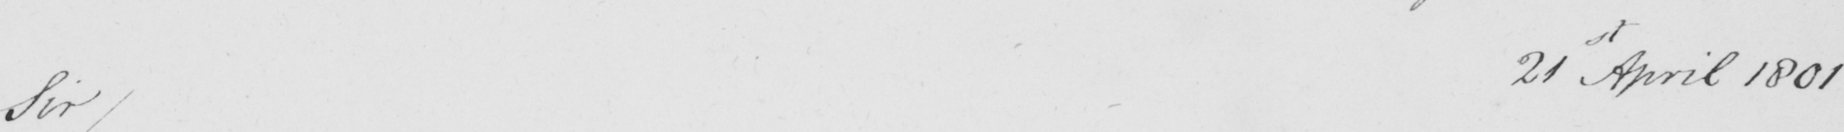What text is written in this handwritten line? Sir/ 21st April 1801 